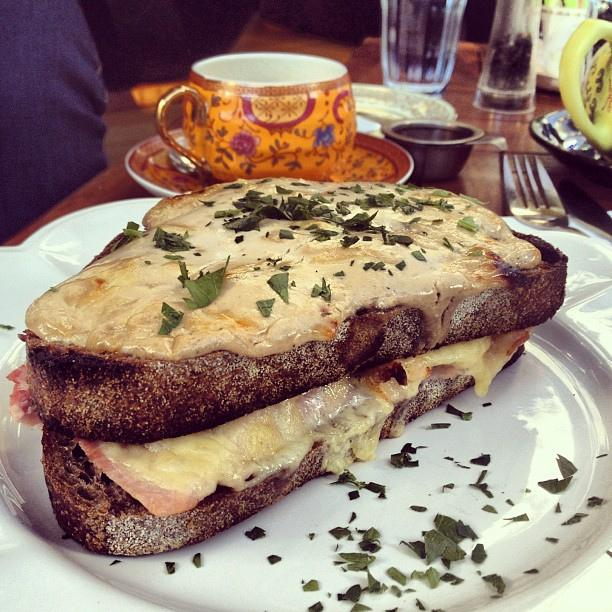What is in the sandwich? Please explain your reasoning. cheese. Melted cheese with parsley is on top of a toasted sandwich. 